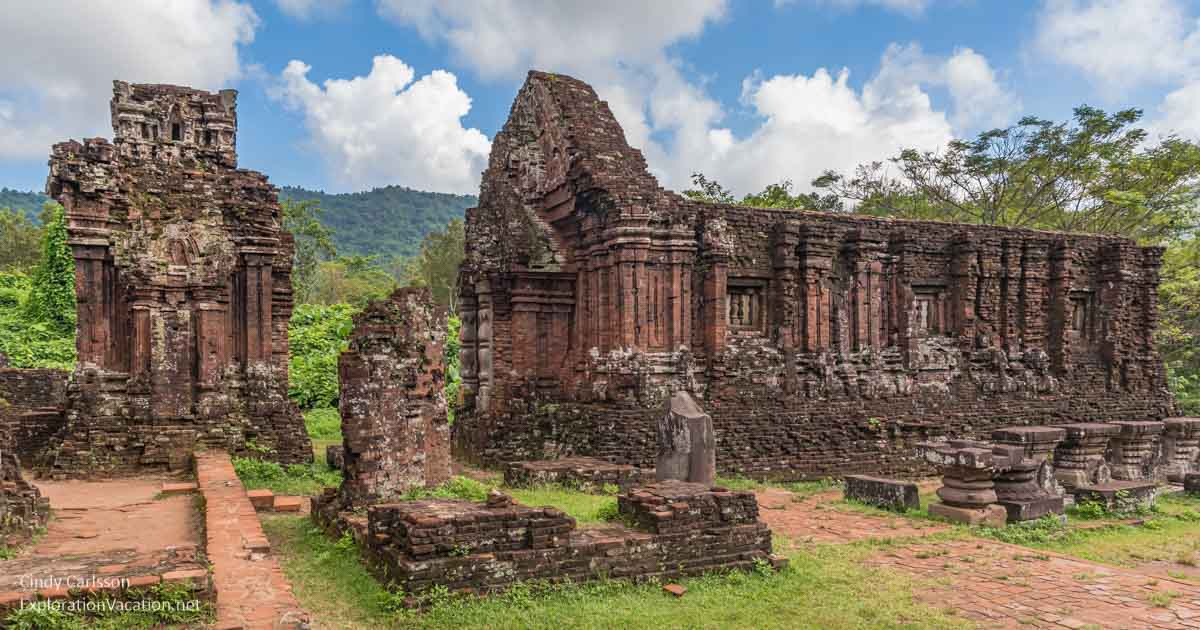Can you describe a day in the life of a priest at this temple during its peak? In the peak of the My Son temple complex's glory, a day in the life of a priest would begin at dawn with rituals of purification, including bathing in the nearby sacred river. The priest would then make offerings of flowers, fruits, and incense to the deities, performing elaborate chants and mantras to invoke divine blessings. Throughout the day, the priest would oversee various ceremonies – from the crowning of kings to community prayers, ensuring the adherence to sacred timings and astrological alignments. Afternoons might involve teaching young disciples the sacred texts and the art of performing rituals accurately. In the evenings, the priest would lead the community in chants and prayers, extending blessings to those in need. As night fell, the priest would conduct the final rituals of the day, ensuring the deities were honored and the spiritual sanctity of the temple maintained, before retiring to rest, preparing for another day of devotion and service. What kind of interactions might the priest have had with the common people? The priest would have had numerous interactions with the common people, serving as a spiritual guide and advisor. They would seek the priest's counsel on matters ranging from health and harvest to marital and familial issues, looking for divine intervention and blessings. During ceremonies, the priest would lead the community in prayers, offering blessings and performing rituals that ensured communal well-being. The priest also played a crucial role in interpreting omens and astrological signs, guiding the people on auspicious times for planting crops, embarking on journeys, or conducting significant life events. Through these interactions, the priest was a central figure in the social and spiritual life of the community. Imagine a mythical creature resides in the temple ruins. What is it and what role does it play? Imagine a majestic Naga serpent, a mythical creature from Hindu and Buddhist lore, residing in the My Son temple ruins. This Naga, a guardian of the sacred site, symbolizes water and fertility. According to legends, the Naga slumbers beneath the temple grounds, awakening during celestial alignments to weave through the ruins, blessing the land with its life-giving presence. Villagers revere the Naga, offering milk, flowers, and precious gems to appease and gain its favor. The Naga’s lore is interwoven with the temple’s history, believed to protect it from external threats and ensure the prosperity of the surrounding lands. It embodies the ancient connection between the human, natural, and divine realms, deeply rooted in the region’s spiritual beliefs and practices. 